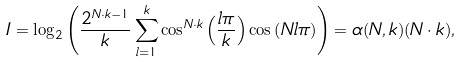Convert formula to latex. <formula><loc_0><loc_0><loc_500><loc_500>I = \log _ { 2 } \left ( \frac { 2 ^ { N \cdot k - 1 } } { k } \sum _ { l = 1 } ^ { k } \cos ^ { N \cdot k } \left ( \frac { l \pi } { k } \right ) \cos \left ( { N l \pi } \right ) \right ) = \alpha ( N , k ) ( N \cdot k ) ,</formula> 